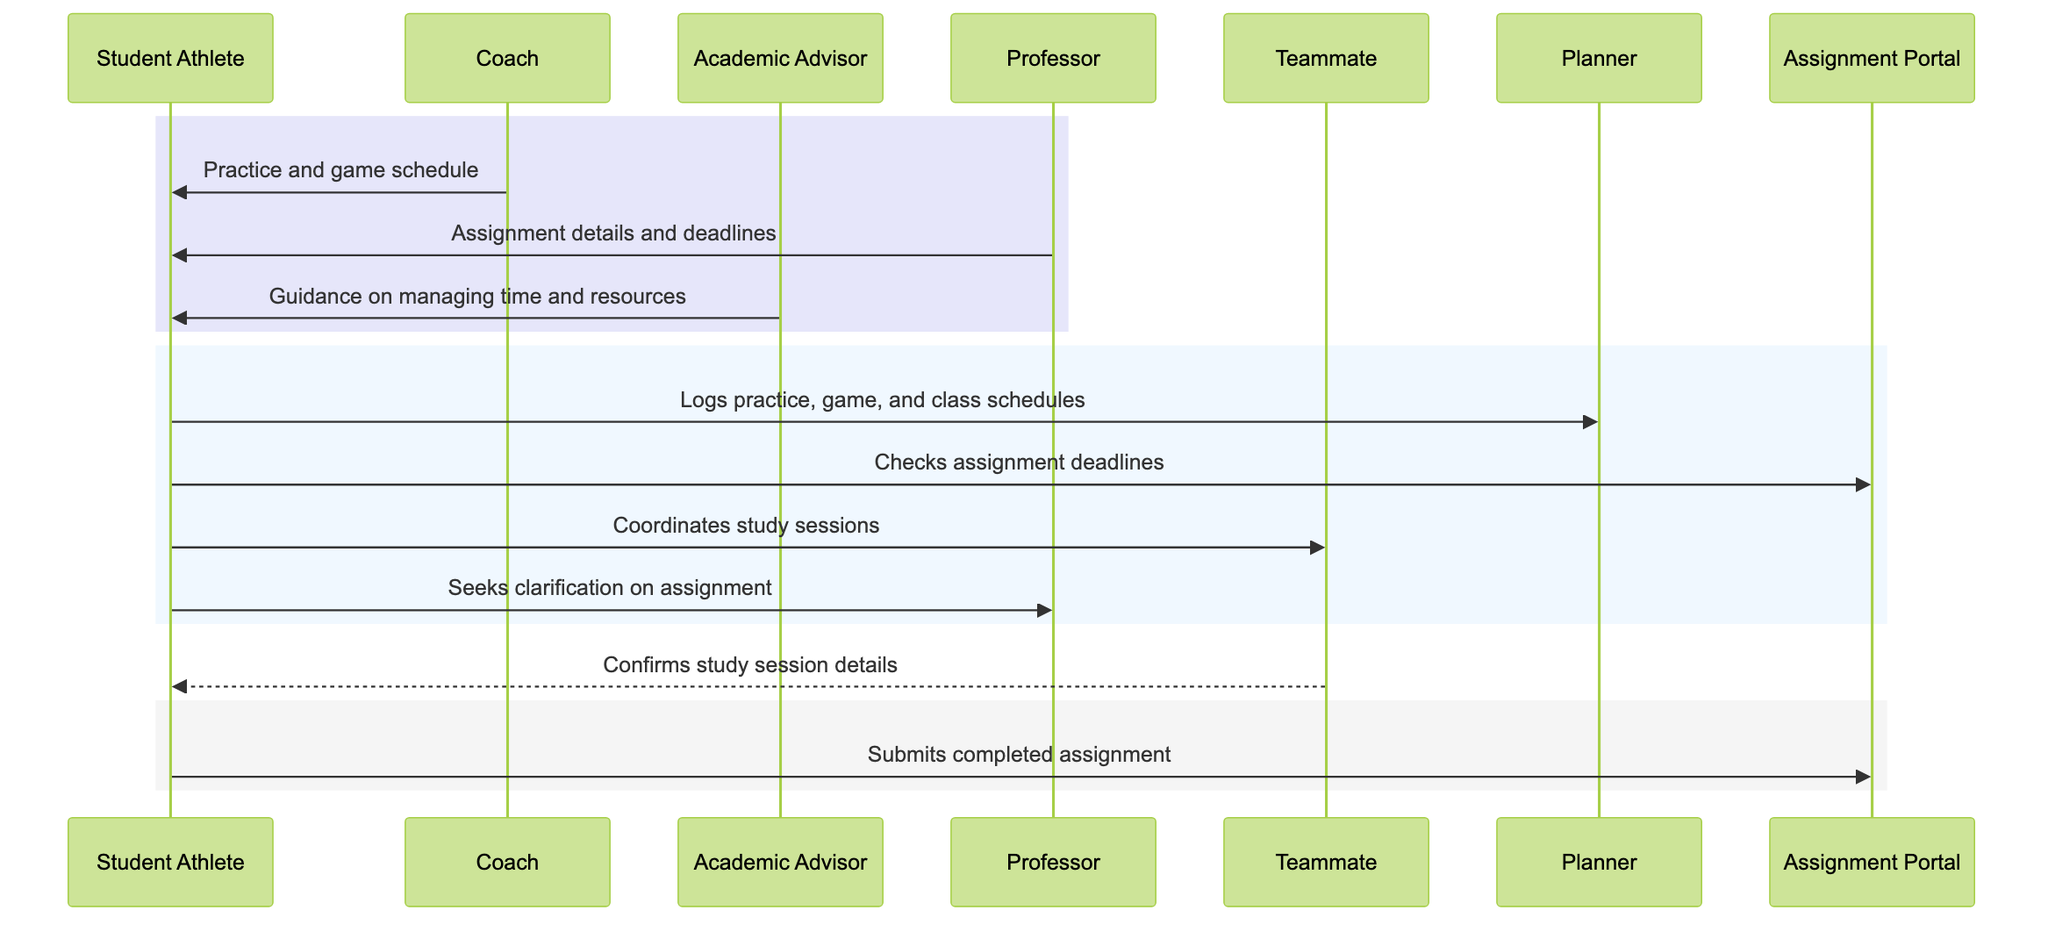What is the role of the Coach in this workflow? The Coach provides the practice and game schedule to the Student Athlete, which is one of the initial steps in the workflow.
Answer: provides practice and game schedules How many actors are present in the diagram? By counting the distinct actors listed—Student Athlete, Coach, Academic Advisor, Professor, and Teammate—we find that there are five actors participating in the workflow.
Answer: 5 What does the Student Athlete check in the Assignment Portal? The Student Athlete checks assignment deadlines in the Assignment Portal as part of managing their academic workload.
Answer: assignment deadlines Which participant does the Student Athlete seek clarification from regarding assignments? The Student Athlete actively seeks clarification on assignments from the Professor, as indicated in the messaging sequence.
Answer: Professor Which action occurs immediately after the Student Athlete logs schedules in the Planner? After logging the schedules, the Student Athlete proceeds to check the assignment deadlines in the Assignment Portal, making it the action that follows directly.
Answer: Checks assignment deadlines What is the purpose of the Academic Advisor’s message to the Student Athlete? The message from the Academic Advisor offers guidance on managing time and resources, playing a crucial role in supporting the Student Athlete's academic journey.
Answer: Guidance on managing time and resources How does the Student Athlete coordinate study sessions? The Student Athlete coordinates study sessions by communicating directly with a Teammate, which demonstrates collaboration in managing academic responsibilities.
Answer: Coordinates study sessions What occurs at the final stage of the workflow? At the final stage of the workflow, the Student Athlete submits the completed assignment through the Assignment Portal, indicating the conclusion of the academic task process.
Answer: Submits completed assignment 